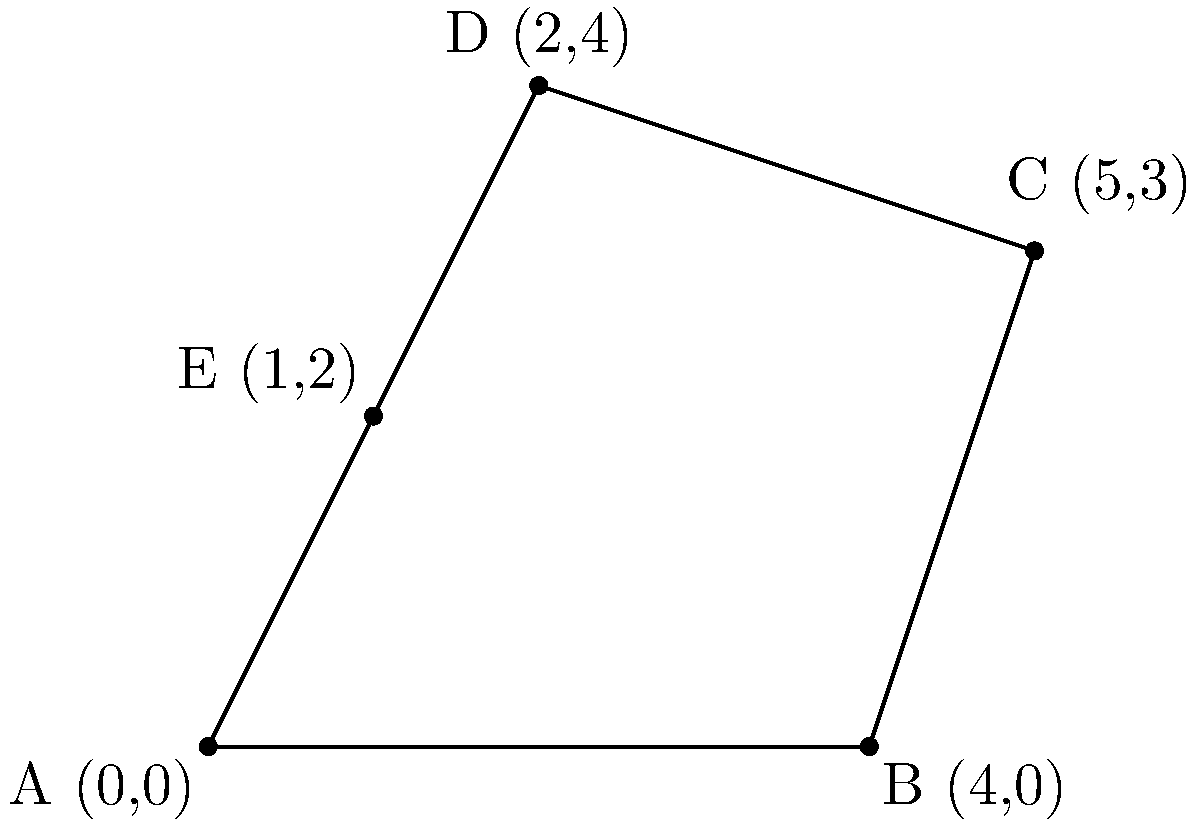As the accountant responsible for calculating the club's property assets, you need to determine the area of an irregularly shaped plot of land. The land's boundary is represented by a polygon with vertices A(0,0), B(4,0), C(5,3), D(2,4), and E(1,2). Using the shoelace formula, calculate the area of this polygon to the nearest square unit. To solve this problem, we'll use the shoelace formula, which is particularly useful for calculating the area of a polygon given its vertices' coordinates. The formula is:

$$ \text{Area} = \frac{1}{2}|(x_1y_2 + x_2y_3 + ... + x_ny_1) - (y_1x_2 + y_2x_3 + ... + y_nx_1)| $$

Where $(x_i, y_i)$ are the coordinates of the $i$-th vertex.

Step 1: List the coordinates in order:
A(0,0), B(4,0), C(5,3), D(2,4), E(1,2)

Step 2: Apply the shoelace formula:

$$ \begin{align*}
\text{Area} &= \frac{1}{2}|(0\cdot0 + 4\cdot3 + 5\cdot4 + 2\cdot2 + 1\cdot0) - (0\cdot4 + 0\cdot5 + 3\cdot2 + 4\cdot1 + 2\cdot0)| \\
&= \frac{1}{2}|(0 + 12 + 20 + 4 + 0) - (0 + 0 + 6 + 4 + 0)| \\
&= \frac{1}{2}|36 - 10| \\
&= \frac{1}{2} \cdot 26 \\
&= 13
\end{align*} $$

Step 3: Round to the nearest square unit:
The area is already a whole number, so no rounding is necessary.

Therefore, the area of the polygon is 13 square units.
Answer: 13 square units 